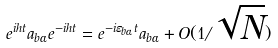<formula> <loc_0><loc_0><loc_500><loc_500>e ^ { i h t } a _ { b \alpha } e ^ { - i h t } = e ^ { - i \varepsilon _ { b \alpha } t } a _ { b \alpha } + O ( 1 / \sqrt { N } )</formula> 